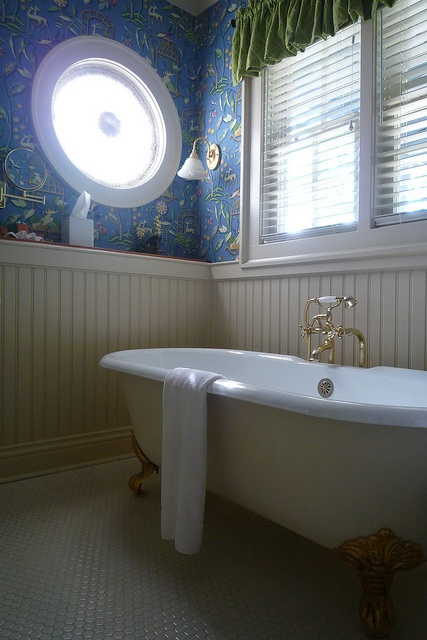Describe the objects in this image and their specific colors. I can see various objects in this image with different colors. 